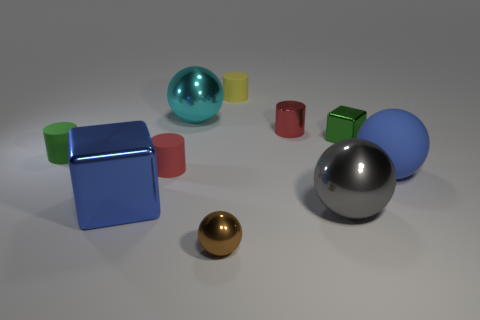Subtract all tiny green cylinders. How many cylinders are left? 3 Subtract all blue cubes. How many red cylinders are left? 2 Subtract all blue spheres. How many spheres are left? 3 Subtract 2 cylinders. How many cylinders are left? 2 Subtract all cubes. How many objects are left? 8 Subtract 1 yellow cylinders. How many objects are left? 9 Subtract all yellow cylinders. Subtract all cyan spheres. How many cylinders are left? 3 Subtract all blue objects. Subtract all small balls. How many objects are left? 7 Add 2 red metal objects. How many red metal objects are left? 3 Add 7 small metal objects. How many small metal objects exist? 10 